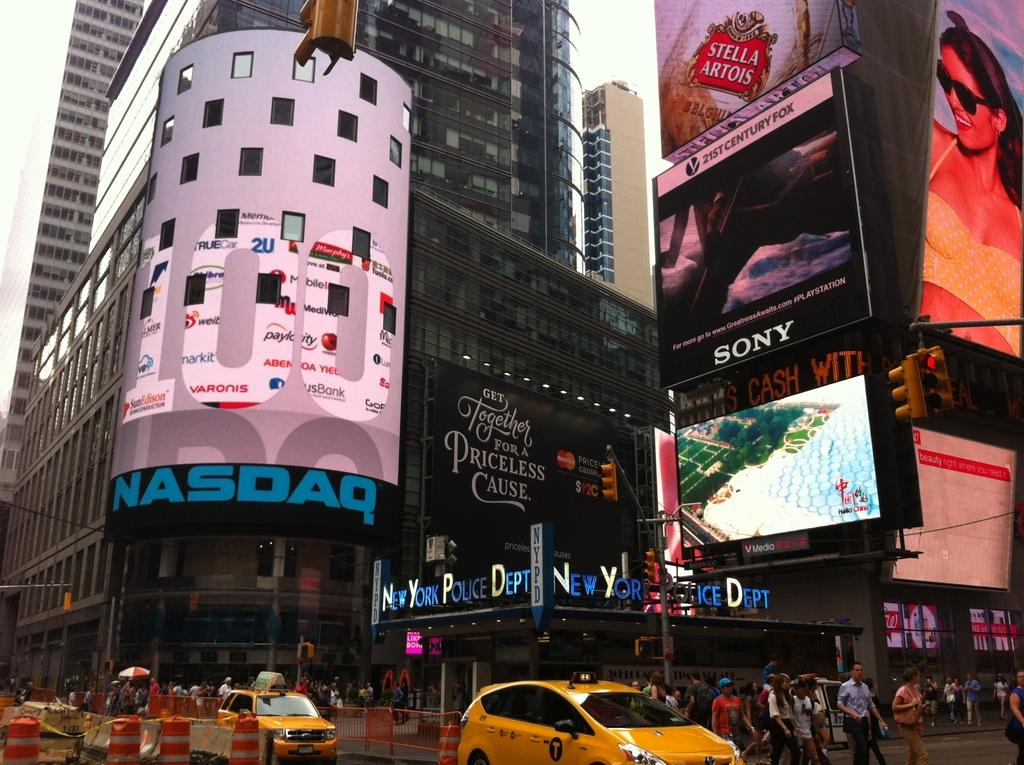Provide a one-sentence caption for the provided image. A street in New York City near the New York Police Department. 